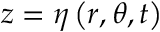Convert formula to latex. <formula><loc_0><loc_0><loc_500><loc_500>z = \eta \left ( r , \theta , t \right )</formula> 